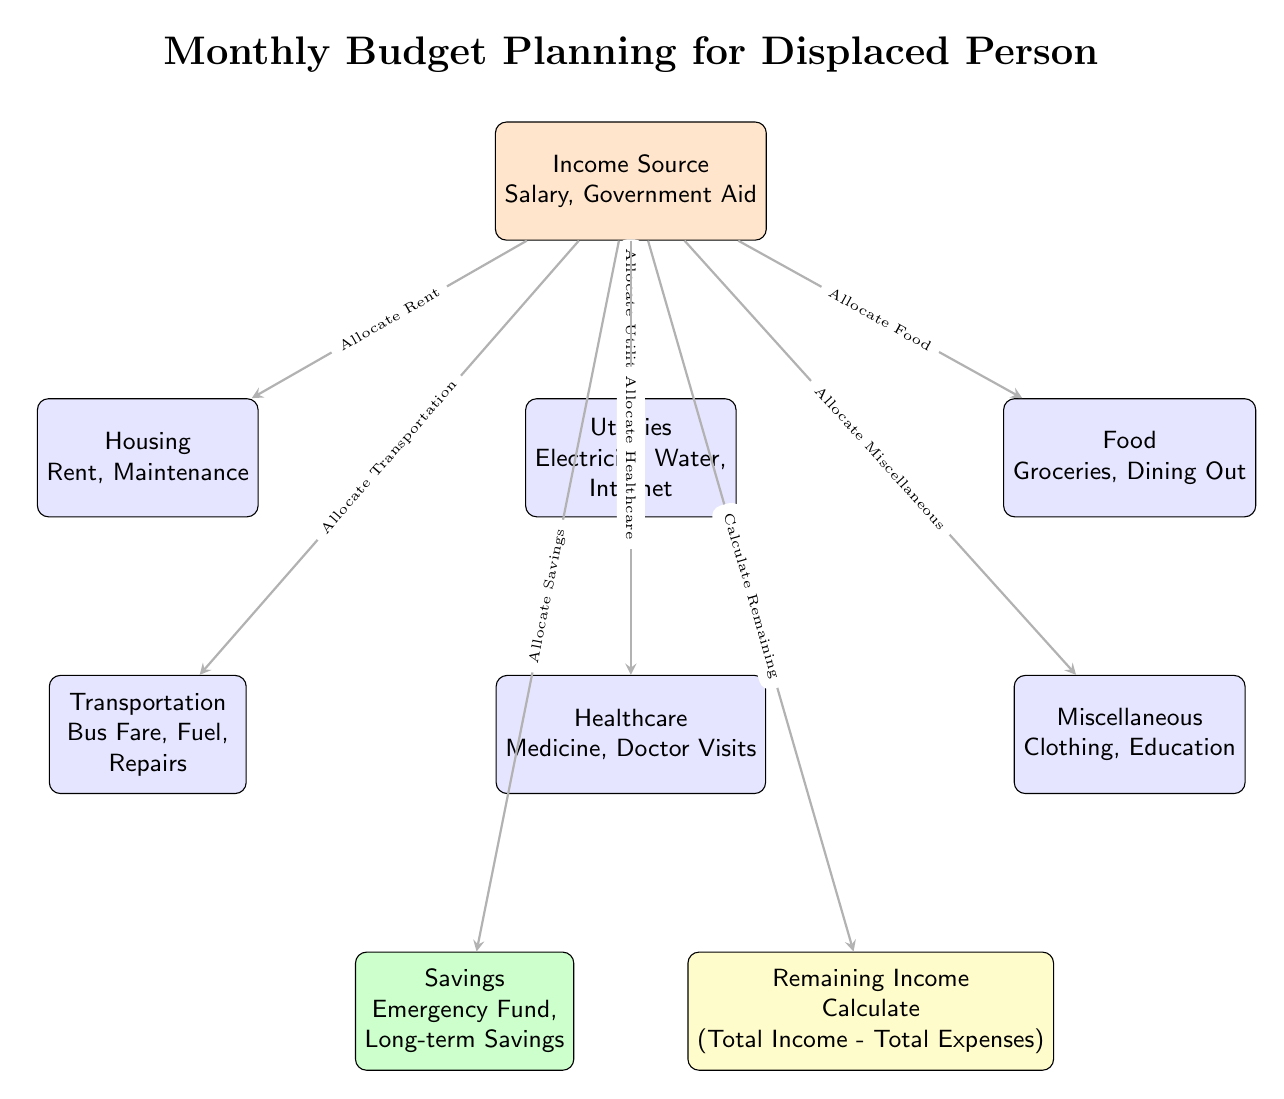What is the main title of the diagram? The title is located at the top of the diagram, clearly labeled and in a larger font, stating the focus of the content.
Answer: Monthly Budget Planning for Displaced Person How many main expense categories are listed in the diagram? By observing the nodes directly below the income source node, we can count the categories. These include Housing, Utilities, Food, Transportation, Healthcare, and Miscellaneous.
Answer: 6 What does the green node represent? The green node is located to the lower left of the Healthcare node and is labeled. It indicates a specific category of budgeting focus related to saving money.
Answer: Savings What is the relationship between Income and Remaining Income? The diagram illustrates a directional flow, where Remaining Income is derived from the calculation of Total Income minus Total Expenses, showcasing a relationship of financial calculation.
Answer: Calculate Which two nodes have the most direct connection in the diagram? Looking at the connections, the node labeled Income has direct arrows to multiple expense categories and Savings, but the most direct connection in terms of expense calculation is between Income and Remaining Income.
Answer: Remaining Income What is one example of a cost listed under Utilities? Within the Utilities node, specific expenses are mentioned, and by examining the sub-items listed, one can identify particular necessities associated with utility costs.
Answer: Electricity How is the Remaining Income calculated according to the diagram? The diagram explicitly shows that the Remaining Income results from subtracting Total Expenses from Total Income. This requires assessing all the expenses listed in the relevant nodes compared to the total income node.
Answer: Total Income - Total Expenses What type of budgeting example is shown in the Miscellaneous node? The Miscellaneous node includes examples of various additional expenses, representing items that are not categorized under the main expense categories but still require budgeting consideration.
Answer: Clothing What elements are included under Food expenses? In the Food node, by analyzing the items mentioned directly under it, we can identify common expenses related to the acquisition of food.
Answer: Groceries, Dining Out 